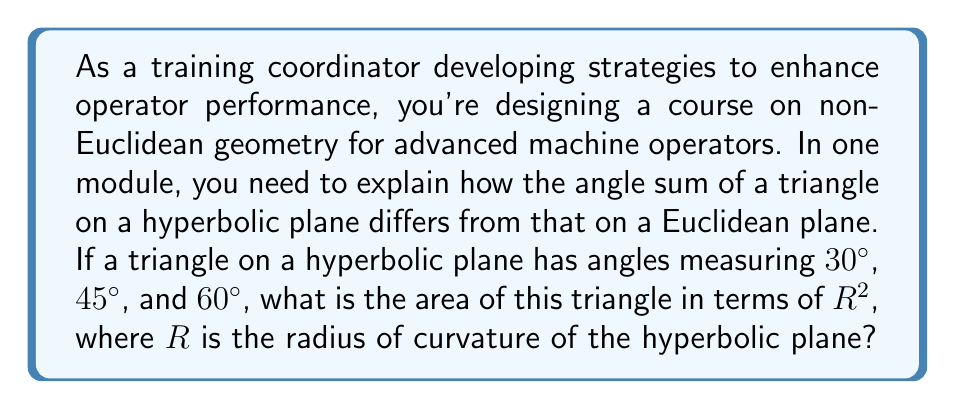Teach me how to tackle this problem. Let's approach this step-by-step:

1) In Euclidean geometry, the angle sum of a triangle is always 180°. However, in hyperbolic geometry, this is not the case.

2) On a hyperbolic plane, the angle sum of a triangle is always less than 180°. The difference between 180° and the actual angle sum is related to the area of the triangle.

3) The formula for the area $A$ of a triangle on a hyperbolic plane with angles $\alpha$, $\beta$, and $\gamma$ is:

   $$A = R^2(\pi - \alpha - \beta - \gamma)$$

   where $R$ is the radius of curvature of the hyperbolic plane.

4) In our case, we have:
   $\alpha = 30° = \frac{\pi}{6}$ radians
   $\beta = 45° = \frac{\pi}{4}$ radians
   $\gamma = 60° = \frac{\pi}{3}$ radians

5) Substituting these into our formula:

   $$A = R^2(\pi - \frac{\pi}{6} - \frac{\pi}{4} - \frac{\pi}{3})$$

6) Simplifying:
   $$A = R^2(\pi - \frac{2\pi}{12} - \frac{3\pi}{12} - \frac{4\pi}{12})$$
   $$A = R^2(\pi - \frac{9\pi}{12})$$
   $$A = R^2(\frac{12\pi}{12} - \frac{9\pi}{12})$$
   $$A = R^2(\frac{3\pi}{12})$$
   $$A = R^2(\frac{\pi}{4})$$

Therefore, the area of the triangle is $\frac{\pi}{4}R^2$.
Answer: $\frac{\pi}{4}R^2$ 